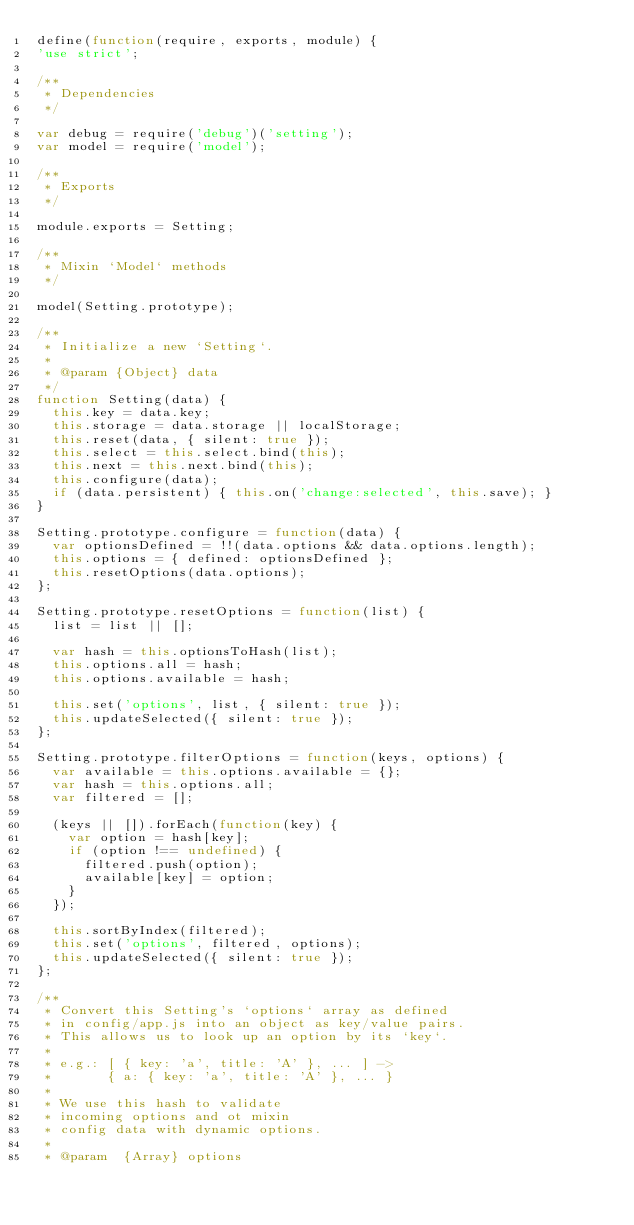<code> <loc_0><loc_0><loc_500><loc_500><_JavaScript_>define(function(require, exports, module) {
'use strict';

/**
 * Dependencies
 */

var debug = require('debug')('setting');
var model = require('model');

/**
 * Exports
 */

module.exports = Setting;

/**
 * Mixin `Model` methods
 */

model(Setting.prototype);

/**
 * Initialize a new `Setting`.
 *
 * @param {Object} data
 */
function Setting(data) {
  this.key = data.key;
  this.storage = data.storage || localStorage;
  this.reset(data, { silent: true });
  this.select = this.select.bind(this);
  this.next = this.next.bind(this);
  this.configure(data);
  if (data.persistent) { this.on('change:selected', this.save); }
}

Setting.prototype.configure = function(data) {
  var optionsDefined = !!(data.options && data.options.length);
  this.options = { defined: optionsDefined };
  this.resetOptions(data.options);
};

Setting.prototype.resetOptions = function(list) {
  list = list || [];

  var hash = this.optionsToHash(list);
  this.options.all = hash;
  this.options.available = hash;

  this.set('options', list, { silent: true });
  this.updateSelected({ silent: true });
};

Setting.prototype.filterOptions = function(keys, options) {
  var available = this.options.available = {};
  var hash = this.options.all;
  var filtered = [];

  (keys || []).forEach(function(key) {
    var option = hash[key];
    if (option !== undefined) {
      filtered.push(option);
      available[key] = option;
    }
  });

  this.sortByIndex(filtered);
  this.set('options', filtered, options);
  this.updateSelected({ silent: true });
};

/**
 * Convert this Setting's `options` array as defined
 * in config/app.js into an object as key/value pairs.
 * This allows us to look up an option by its `key`.
 *
 * e.g.: [ { key: 'a', title: 'A' }, ... ] ->
 *       { a: { key: 'a', title: 'A' }, ... }
 *
 * We use this hash to validate
 * incoming options and ot mixin
 * config data with dynamic options.
 *
 * @param  {Array} options</code> 